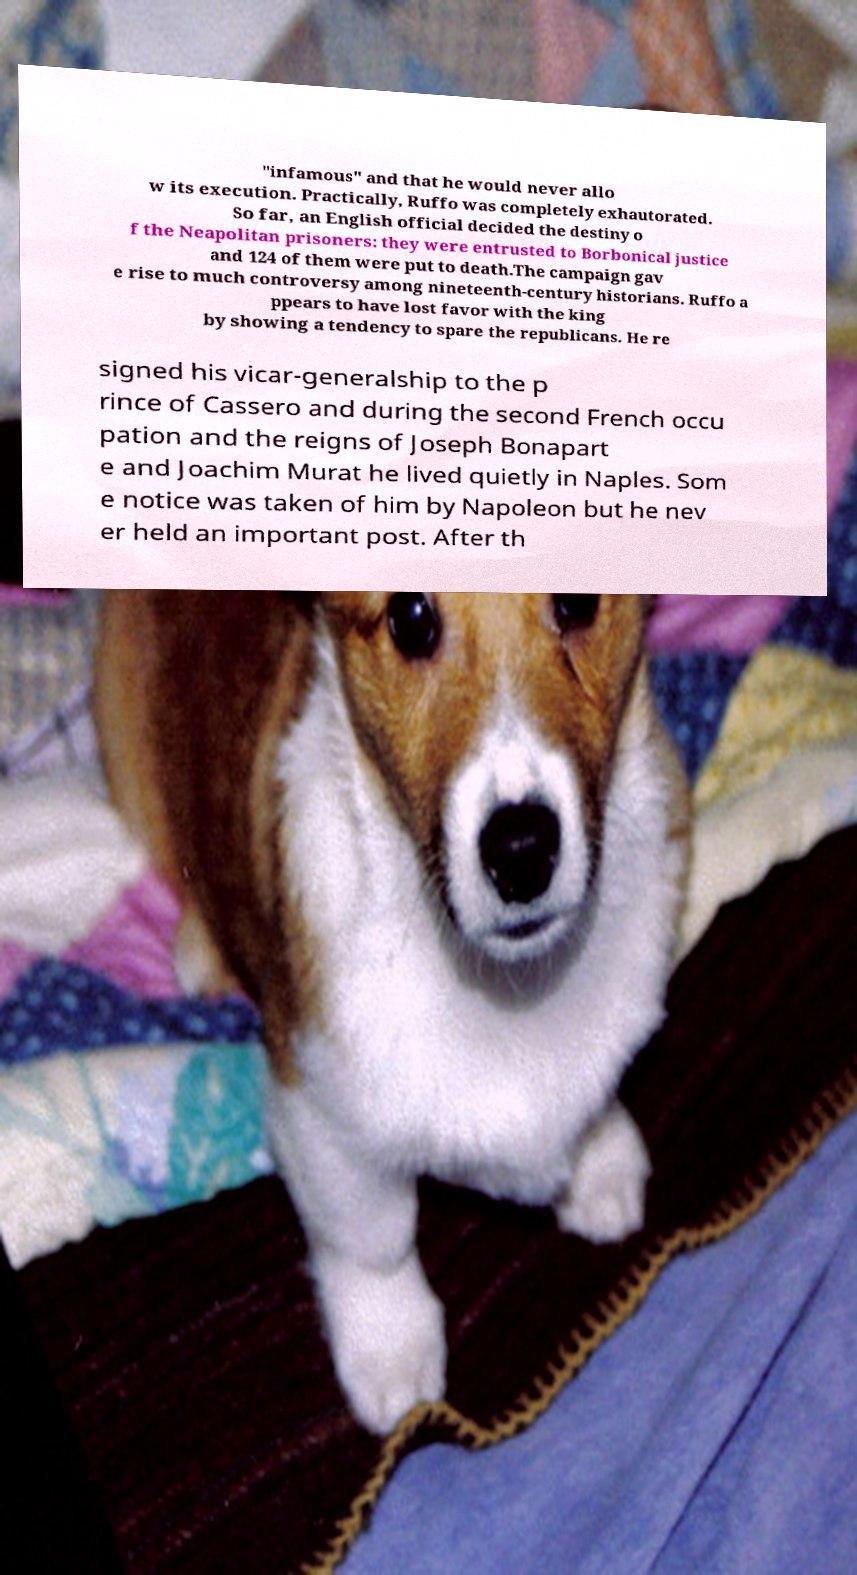Please identify and transcribe the text found in this image. "infamous" and that he would never allo w its execution. Practically, Ruffo was completely exhautorated. So far, an English official decided the destiny o f the Neapolitan prisoners: they were entrusted to Borbonical justice and 124 of them were put to death.The campaign gav e rise to much controversy among nineteenth-century historians. Ruffo a ppears to have lost favor with the king by showing a tendency to spare the republicans. He re signed his vicar-generalship to the p rince of Cassero and during the second French occu pation and the reigns of Joseph Bonapart e and Joachim Murat he lived quietly in Naples. Som e notice was taken of him by Napoleon but he nev er held an important post. After th 